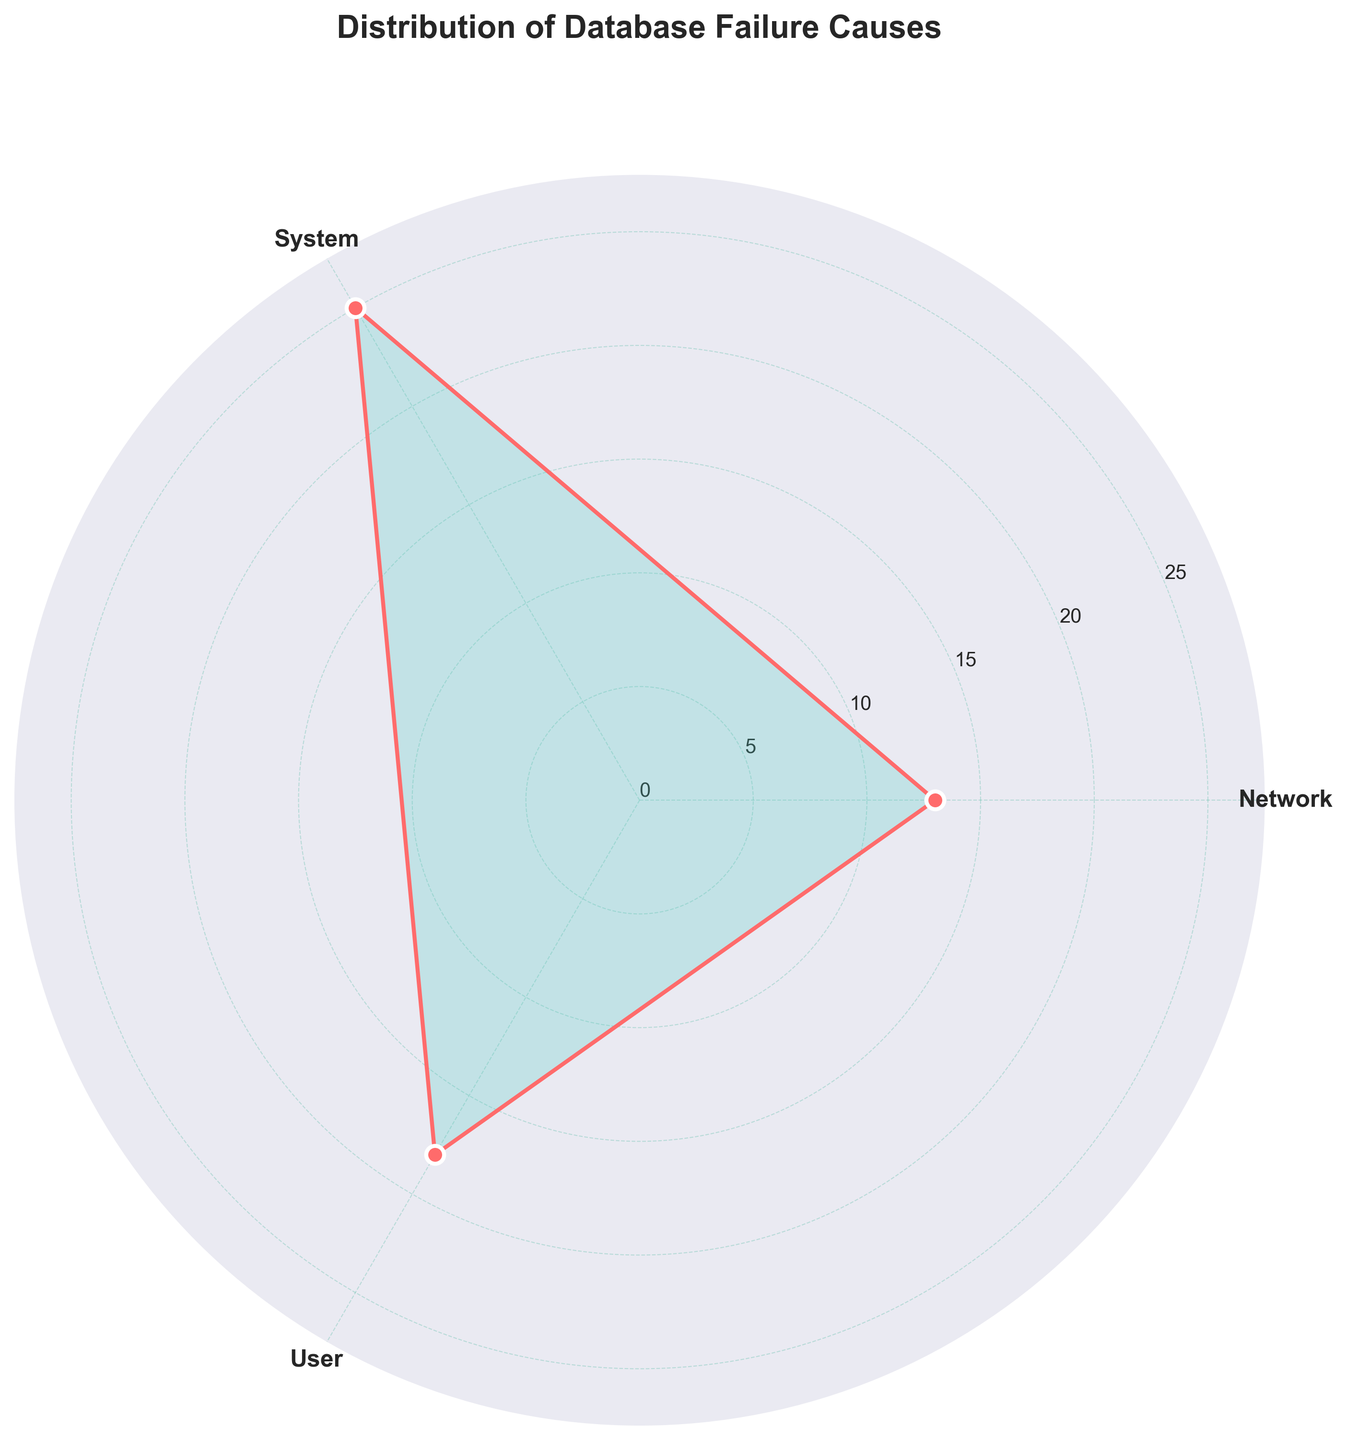What is the title of the plot? The title is shown at the top of the plot in bold. It reads "Distribution of Database Failure Causes".
Answer: Distribution of Database Failure Causes How many categories of database failure causes are there? The plot shows three labeled sections around the chart corresponding to the number of categories.
Answer: 3 Which category of database failure causes has the highest count? Observing the lengths of the sections, the category with the longest section represents the highest count.
Answer: System By how much does the count for network-related failures differ from user-related failures? Network-related failures can be seen by summing the lengths of "Connection Timeout" and "Packet Loss" sections and similarly summing for user-related failures in the "Incorrect Query" and "Permission Error" sections. System (15+10) > Network (8+5) < User (12+6).
Answer: 6 What is the total count of database failures summarized in the chart? The total count is represented by adding up the values around the chart for each section. System (25) + Network (13) + User (18).
Answer: 56 Which category had the least number of counted failures and what is the count? Compare the length of sections visually and identify the smallest one, which represents the lowest failure count.
Answer: Network with 13 Does the chart include visually distinct markers for the data points? The plot has circles at the tip of each section indicating data points.
Answer: Yes What is the count of software bugs in the system category? The chart doesn't show sub-categories directly, only the overall counts and you need to refer to other data for individual sub-counts. Given the dataset: "Software Bug = 10".
Answer: 10 How are the categories distinguished on the chart? Categories are labeled with distinct sections and marked clearly around the chart with corresponding segment counts plotted.
Answer: Labeled Sections What does the plot use to indicate the values for each category? The chart extends different lengths for each section outwards from the center to indicate values relative to category.
Answer: Angular plot sections with radii 